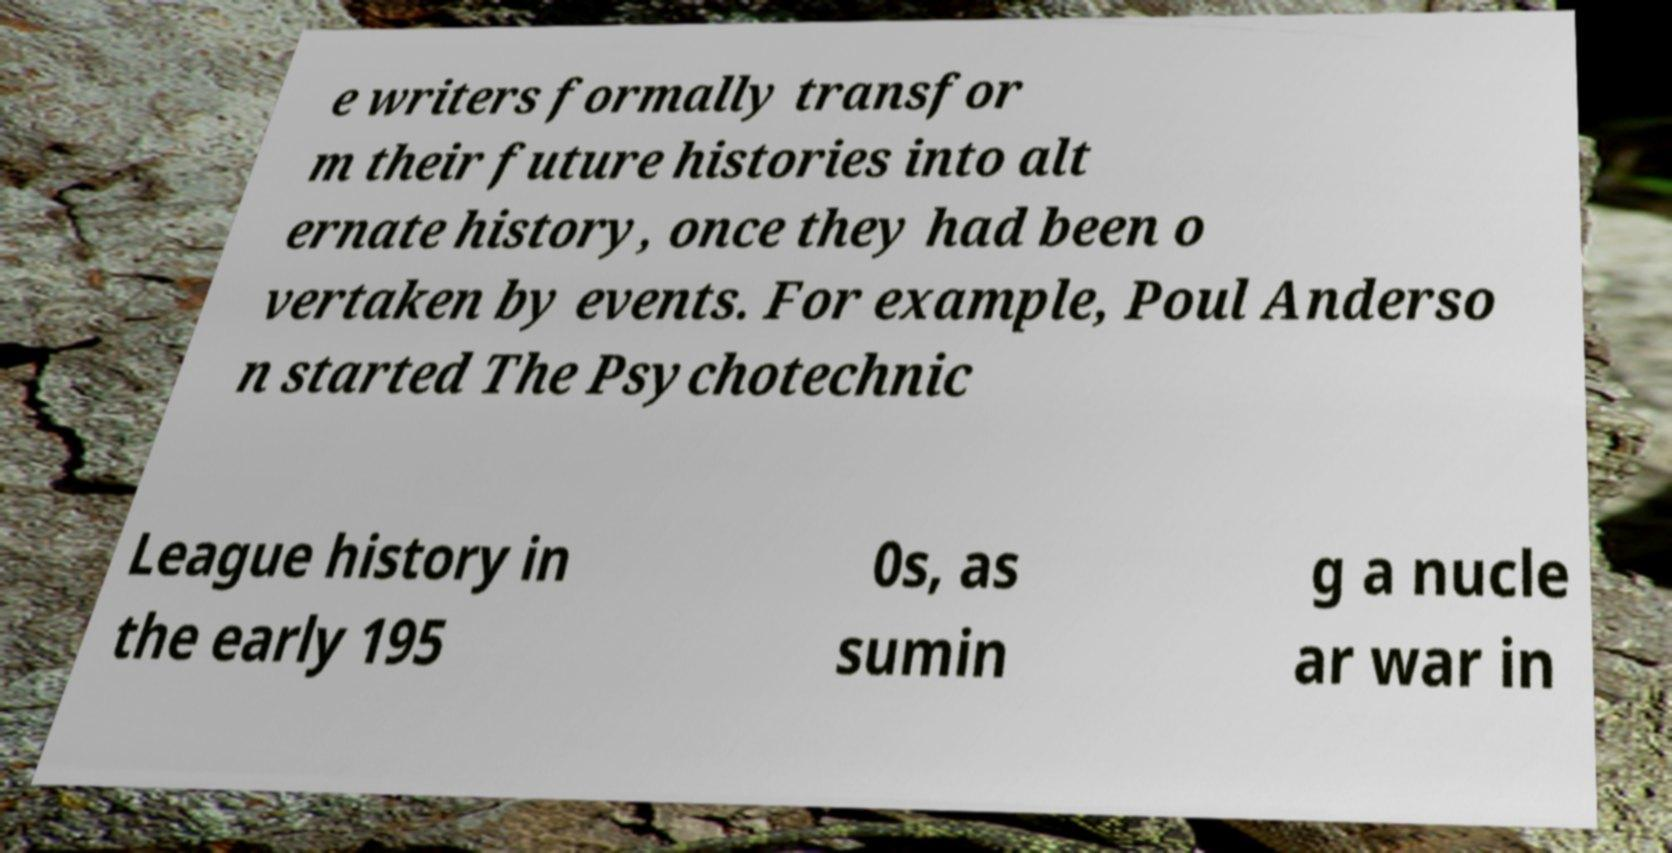I need the written content from this picture converted into text. Can you do that? e writers formally transfor m their future histories into alt ernate history, once they had been o vertaken by events. For example, Poul Anderso n started The Psychotechnic League history in the early 195 0s, as sumin g a nucle ar war in 